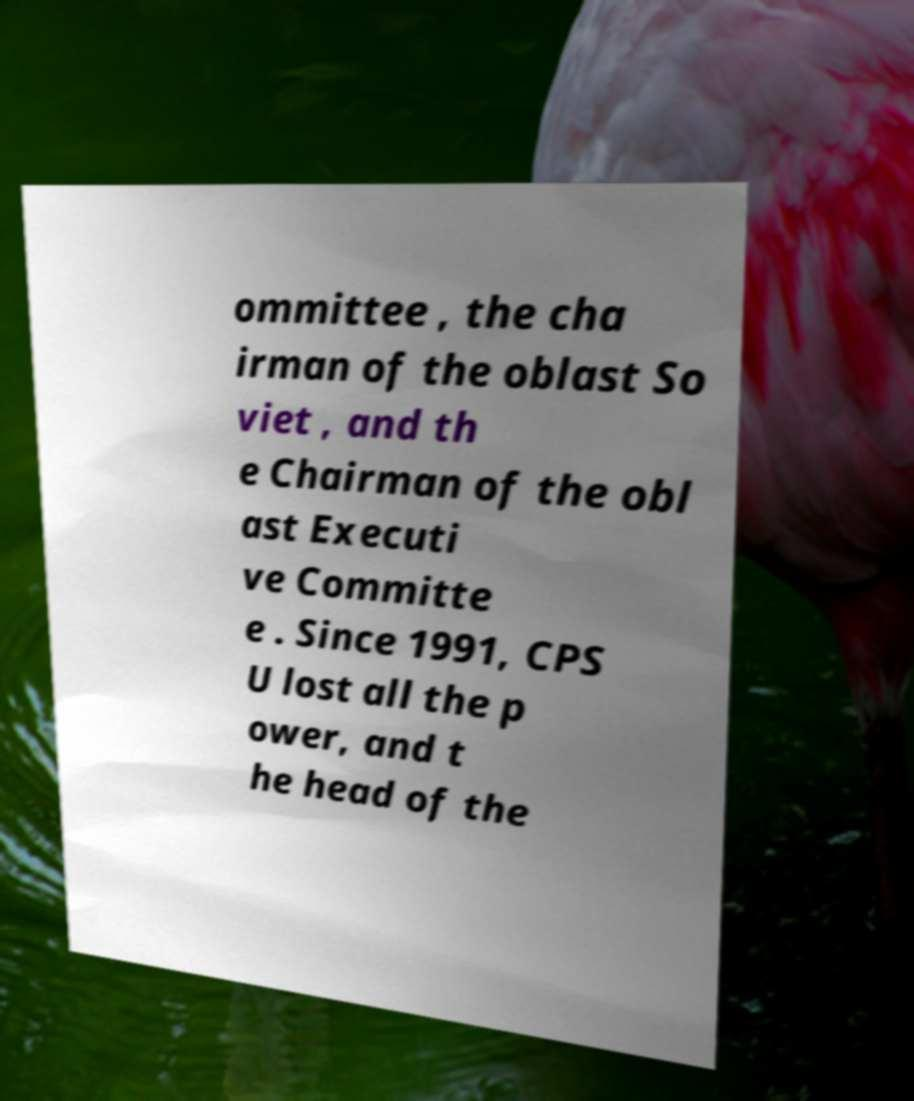Could you assist in decoding the text presented in this image and type it out clearly? ommittee , the cha irman of the oblast So viet , and th e Chairman of the obl ast Executi ve Committe e . Since 1991, CPS U lost all the p ower, and t he head of the 